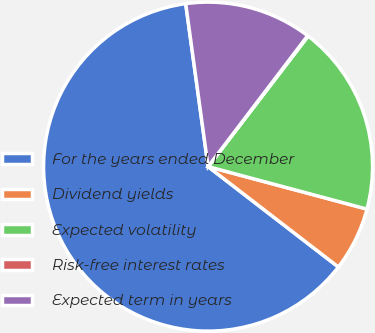<chart> <loc_0><loc_0><loc_500><loc_500><pie_chart><fcel>For the years ended December<fcel>Dividend yields<fcel>Expected volatility<fcel>Risk-free interest rates<fcel>Expected term in years<nl><fcel>62.38%<fcel>6.29%<fcel>18.75%<fcel>0.06%<fcel>12.52%<nl></chart> 